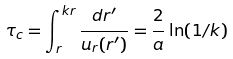Convert formula to latex. <formula><loc_0><loc_0><loc_500><loc_500>\tau _ { c } = \int _ { r } ^ { k r } \frac { d r ^ { \prime } } { u _ { r } ( r ^ { \prime } ) } = \frac { 2 } { a } \ln ( 1 / k )</formula> 